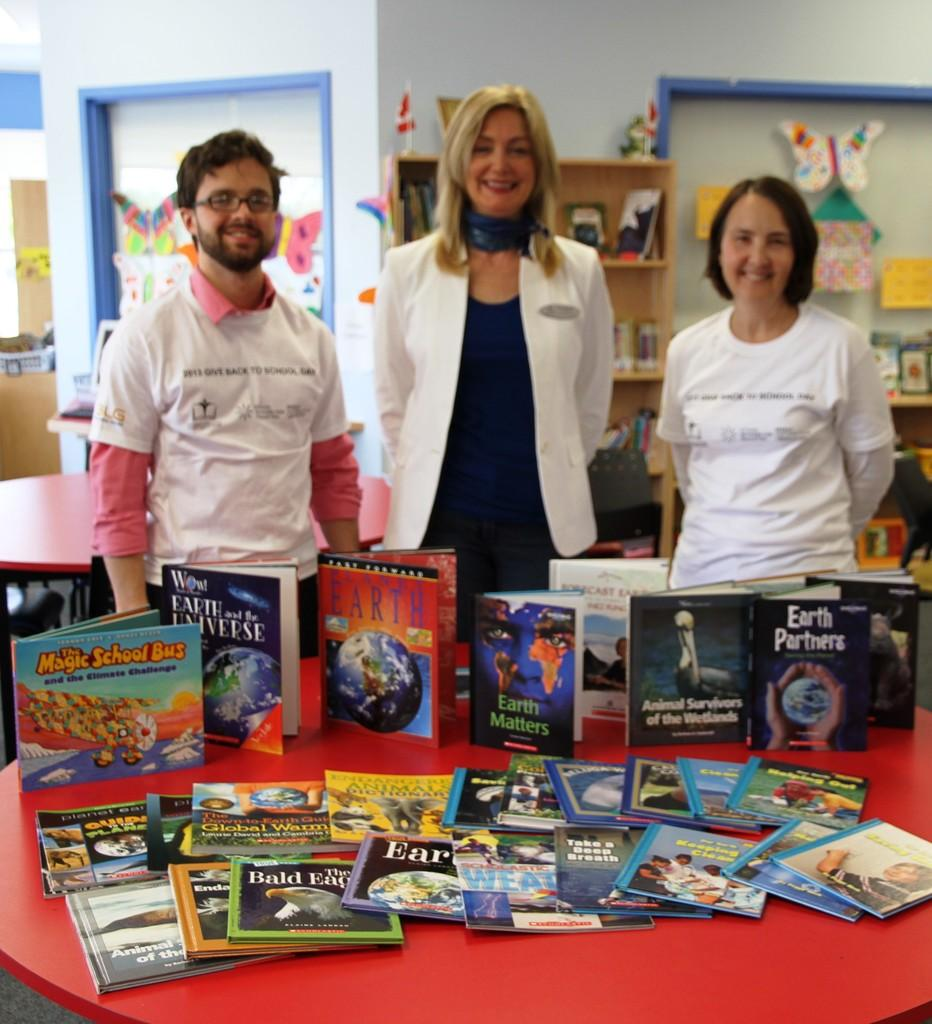<image>
Share a concise interpretation of the image provided. A book titled "The magic school bus and the climate challenge". 